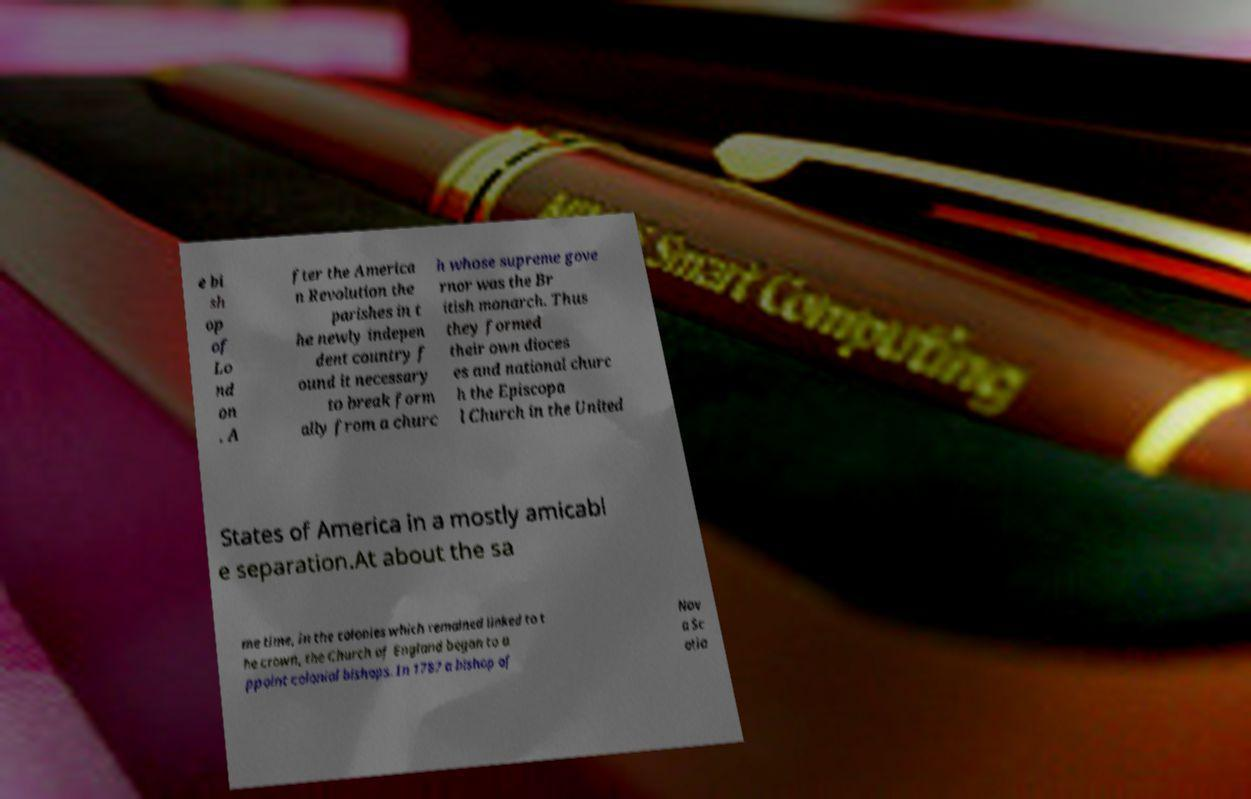I need the written content from this picture converted into text. Can you do that? e bi sh op of Lo nd on . A fter the America n Revolution the parishes in t he newly indepen dent country f ound it necessary to break form ally from a churc h whose supreme gove rnor was the Br itish monarch. Thus they formed their own dioces es and national churc h the Episcopa l Church in the United States of America in a mostly amicabl e separation.At about the sa me time, in the colonies which remained linked to t he crown, the Church of England began to a ppoint colonial bishops. In 1787 a bishop of Nov a Sc otia 